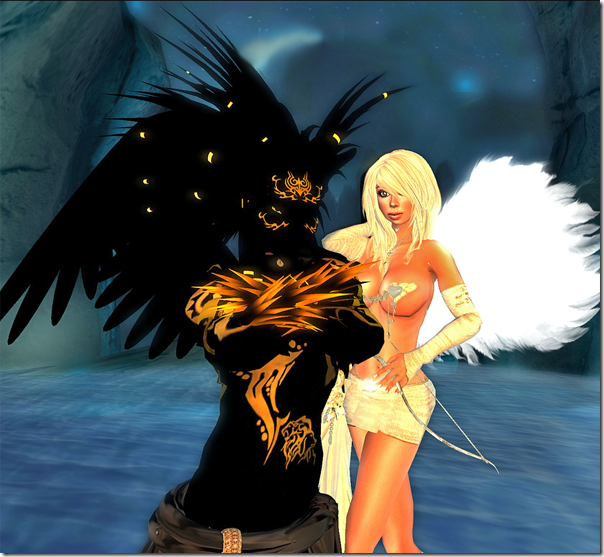Considering the details in the attire and accessories of the characters, what era or cultural influences might have inspired their design? The characters in the image showcase an eclectic fusion of design elements that hint at multiple eras and cultures, interwoven with fantasy themes. The figure clad in dark, with gold trimmings and ornate patterns, evokes the luxurious, detailed craftsmanship reminiscent of the Baroque period, known for its elaborate artistry and dramatic use of contrast. Similarly, the gold embellishments could be drawing influence from various cultures that revered gold, such as Ancient Egyptian or Byzantine civilizations. The ethereal wings and otherworldly aura surrounding both characters suggest a strong inspiration from mythological beings, like angels from Christian lore or mythical creatures from Norse mythology. These designs cleverly blend historical opulence with mythical mystique to create a visually striking and culturally rich aesthetic. 